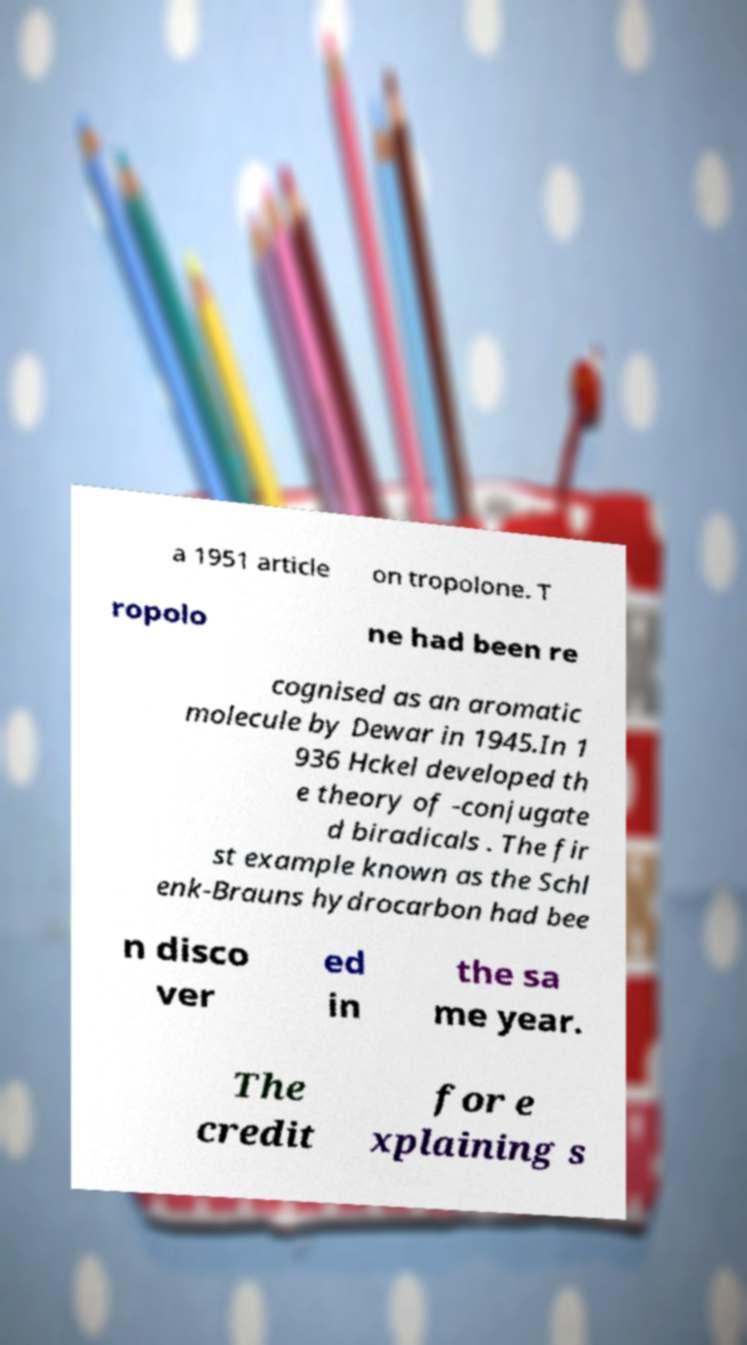Could you extract and type out the text from this image? a 1951 article on tropolone. T ropolo ne had been re cognised as an aromatic molecule by Dewar in 1945.In 1 936 Hckel developed th e theory of -conjugate d biradicals . The fir st example known as the Schl enk-Brauns hydrocarbon had bee n disco ver ed in the sa me year. The credit for e xplaining s 